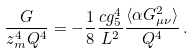Convert formula to latex. <formula><loc_0><loc_0><loc_500><loc_500>\frac { G } { z _ { m } ^ { 4 } Q ^ { 4 } } = - \frac { 1 } { 8 } \frac { c g _ { 5 } ^ { 4 } } { L ^ { 2 } } \frac { \langle \alpha G _ { \mu \nu } ^ { 2 } \rangle } { Q ^ { 4 } } \, .</formula> 